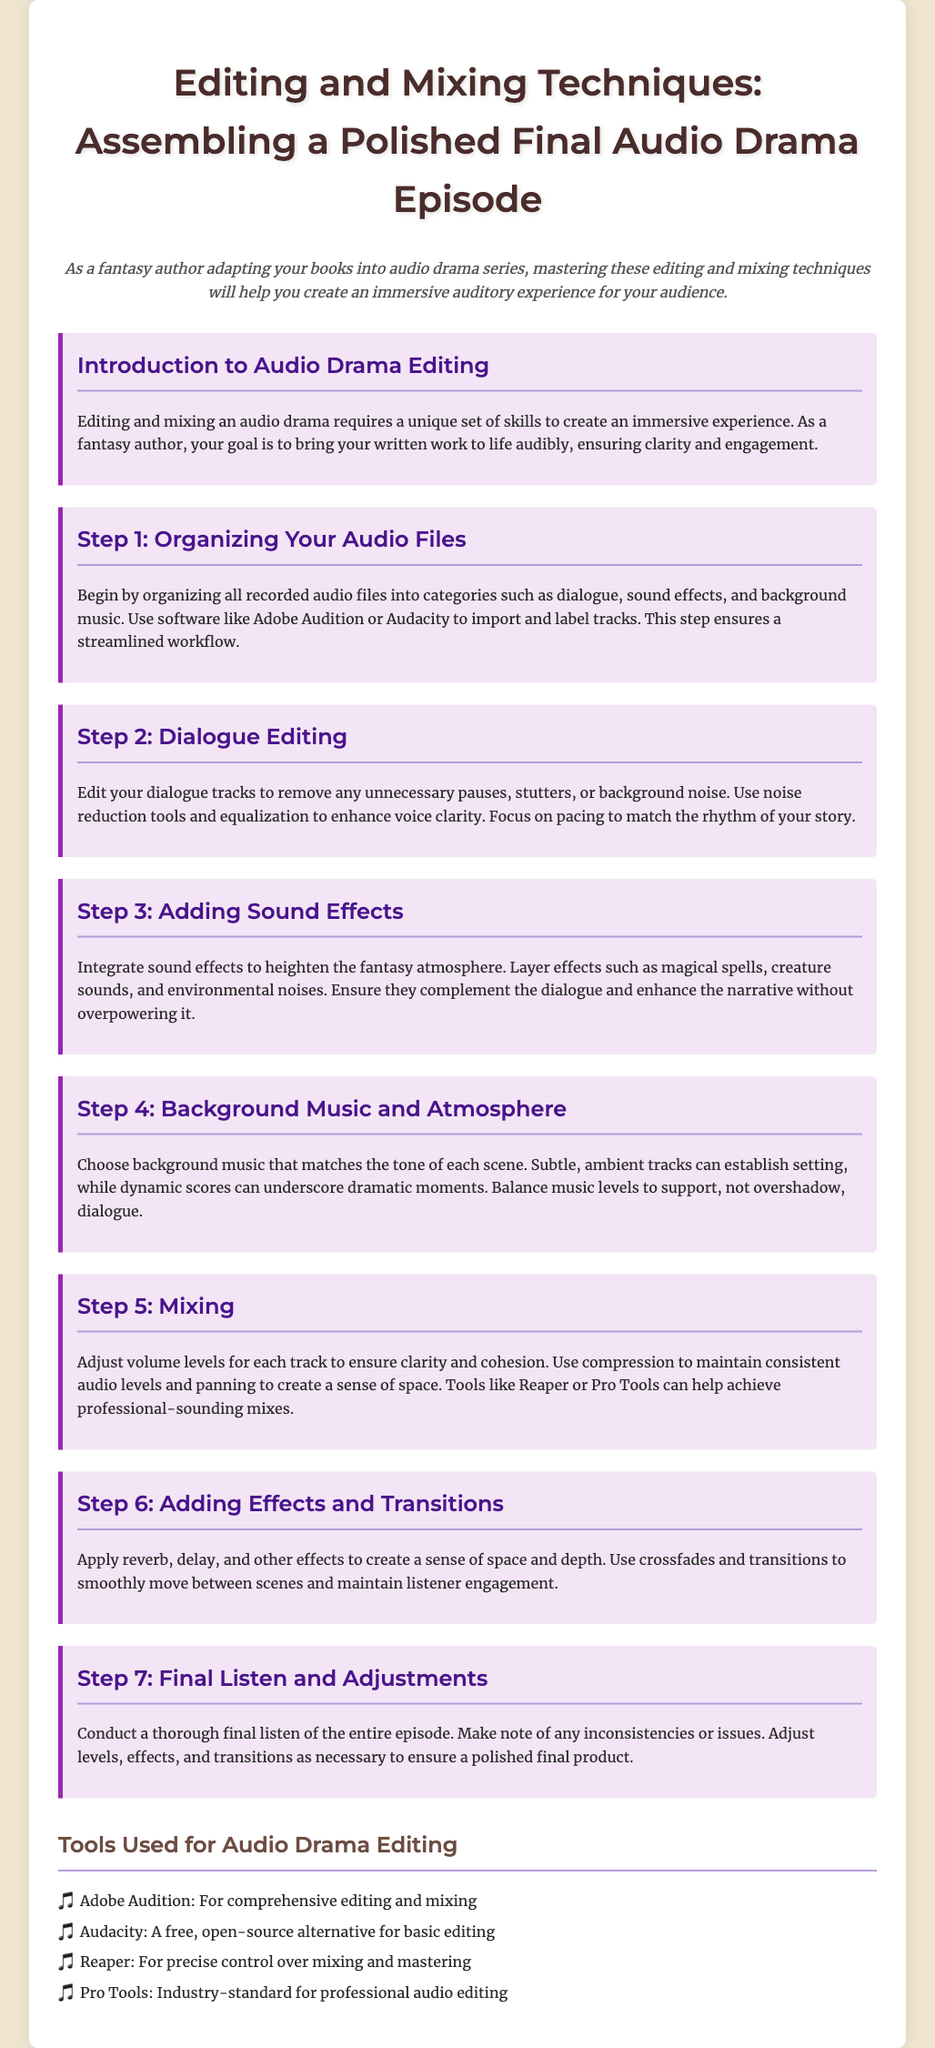What is the main purpose of the document? The document's purpose is to provide techniques for editing and mixing audio drama episodes for fantasy authors.
Answer: Techniques for editing and mixing audio drama episodes What is the first step in audio editing? The first step involves organizing all recorded audio files into categories like dialogue, sound effects, and background music.
Answer: Organizing Your Audio Files Which software can be used for comprehensive editing and mixing? The document lists Adobe Audition as a tool for comprehensive editing and mixing.
Answer: Adobe Audition How many steps are detailed in the document? The document outlines a total of seven steps for audio drama editing.
Answer: Seven steps What should be focused on during dialogue editing? During dialogue editing, emphasis should be placed on removing unnecessary pauses, stutters, or background noise.
Answer: Removing unnecessary pauses, stutters, or background noise For which type of sounds should sound effects be layered? Sound effects should be layered to heighten the fantasy atmosphere, such as magical spells and creature sounds.
Answer: Fantasy atmosphere What is the purpose of using compression during mixing? Compression is used to maintain consistent audio levels during the mixing process.
Answer: Maintain consistent audio levels Where can background music be sourced from? Background music can be chosen based on its match to the tone of each scene within the audio drama.
Answer: Matches the tone of each scene 